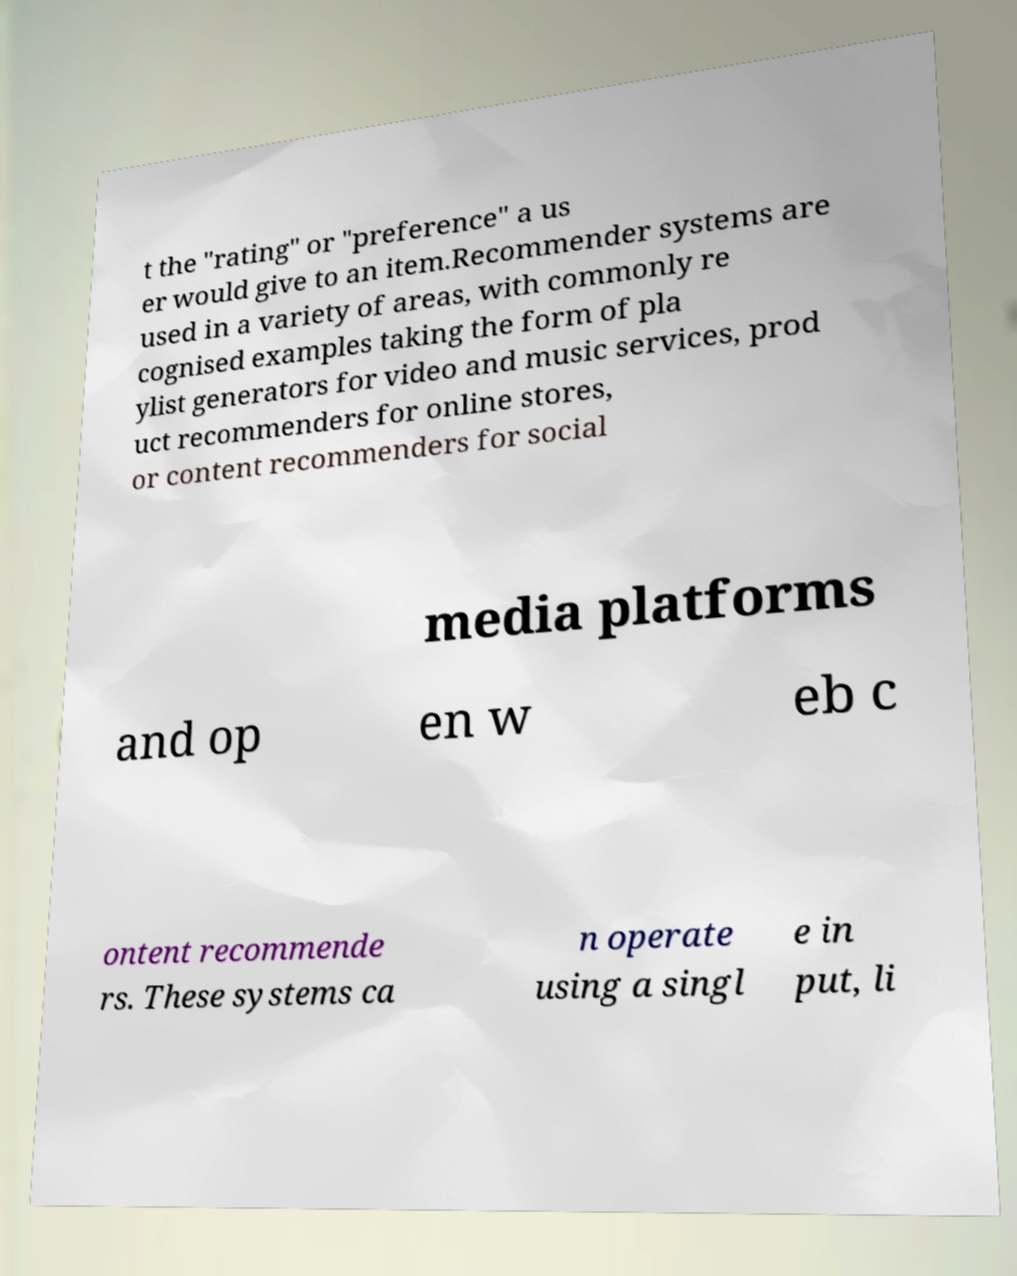There's text embedded in this image that I need extracted. Can you transcribe it verbatim? t the "rating" or "preference" a us er would give to an item.Recommender systems are used in a variety of areas, with commonly re cognised examples taking the form of pla ylist generators for video and music services, prod uct recommenders for online stores, or content recommenders for social media platforms and op en w eb c ontent recommende rs. These systems ca n operate using a singl e in put, li 